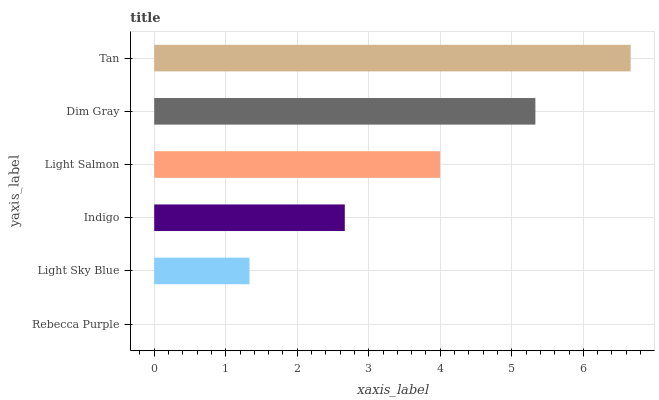Is Rebecca Purple the minimum?
Answer yes or no. Yes. Is Tan the maximum?
Answer yes or no. Yes. Is Light Sky Blue the minimum?
Answer yes or no. No. Is Light Sky Blue the maximum?
Answer yes or no. No. Is Light Sky Blue greater than Rebecca Purple?
Answer yes or no. Yes. Is Rebecca Purple less than Light Sky Blue?
Answer yes or no. Yes. Is Rebecca Purple greater than Light Sky Blue?
Answer yes or no. No. Is Light Sky Blue less than Rebecca Purple?
Answer yes or no. No. Is Light Salmon the high median?
Answer yes or no. Yes. Is Indigo the low median?
Answer yes or no. Yes. Is Tan the high median?
Answer yes or no. No. Is Dim Gray the low median?
Answer yes or no. No. 